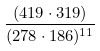Convert formula to latex. <formula><loc_0><loc_0><loc_500><loc_500>\frac { ( 4 1 9 \cdot 3 1 9 ) } { ( 2 7 8 \cdot 1 8 6 ) ^ { 1 1 } }</formula> 